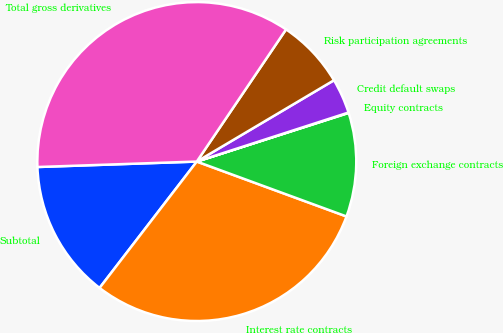<chart> <loc_0><loc_0><loc_500><loc_500><pie_chart><fcel>Subtotal<fcel>Interest rate contracts<fcel>Foreign exchange contracts<fcel>Equity contracts<fcel>Credit default swaps<fcel>Risk participation agreements<fcel>Total gross derivatives<nl><fcel>14.02%<fcel>29.84%<fcel>10.53%<fcel>0.04%<fcel>3.54%<fcel>7.03%<fcel>35.0%<nl></chart> 